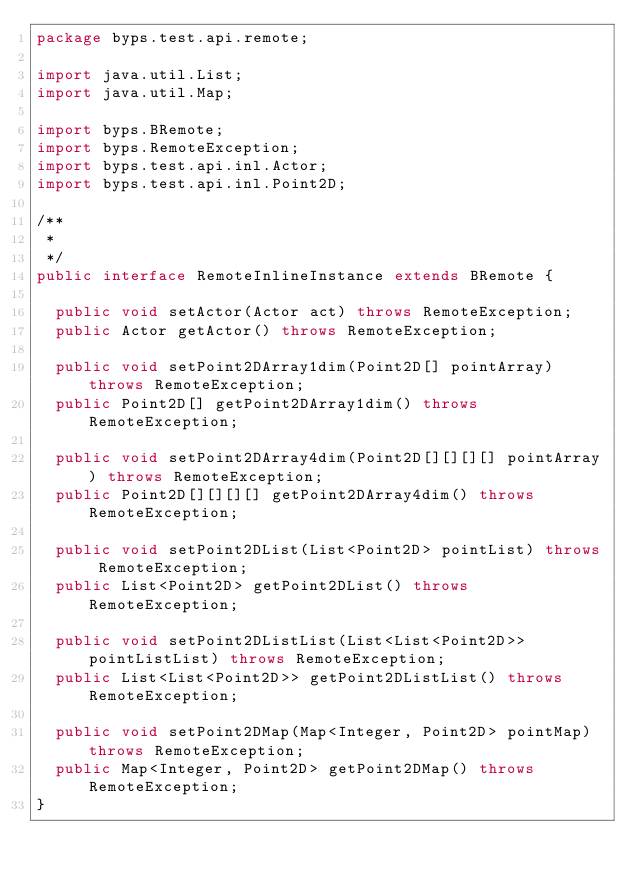<code> <loc_0><loc_0><loc_500><loc_500><_Java_>package byps.test.api.remote;

import java.util.List;
import java.util.Map;

import byps.BRemote;
import byps.RemoteException;
import byps.test.api.inl.Actor;
import byps.test.api.inl.Point2D;

/**
 * 
 */
public interface RemoteInlineInstance extends BRemote {
	
	public void setActor(Actor act) throws RemoteException;
	public Actor getActor() throws RemoteException;

	public void setPoint2DArray1dim(Point2D[] pointArray) throws RemoteException;
	public Point2D[] getPoint2DArray1dim() throws RemoteException;

	public void setPoint2DArray4dim(Point2D[][][][] pointArray) throws RemoteException;
	public Point2D[][][][] getPoint2DArray4dim() throws RemoteException;

	public void setPoint2DList(List<Point2D> pointList) throws RemoteException;
	public List<Point2D> getPoint2DList() throws RemoteException;
	
	public void setPoint2DListList(List<List<Point2D>> pointListList) throws RemoteException;
	public List<List<Point2D>> getPoint2DListList() throws RemoteException;
	
	public void setPoint2DMap(Map<Integer, Point2D> pointMap) throws RemoteException;
	public Map<Integer, Point2D> getPoint2DMap() throws RemoteException;
}
</code> 